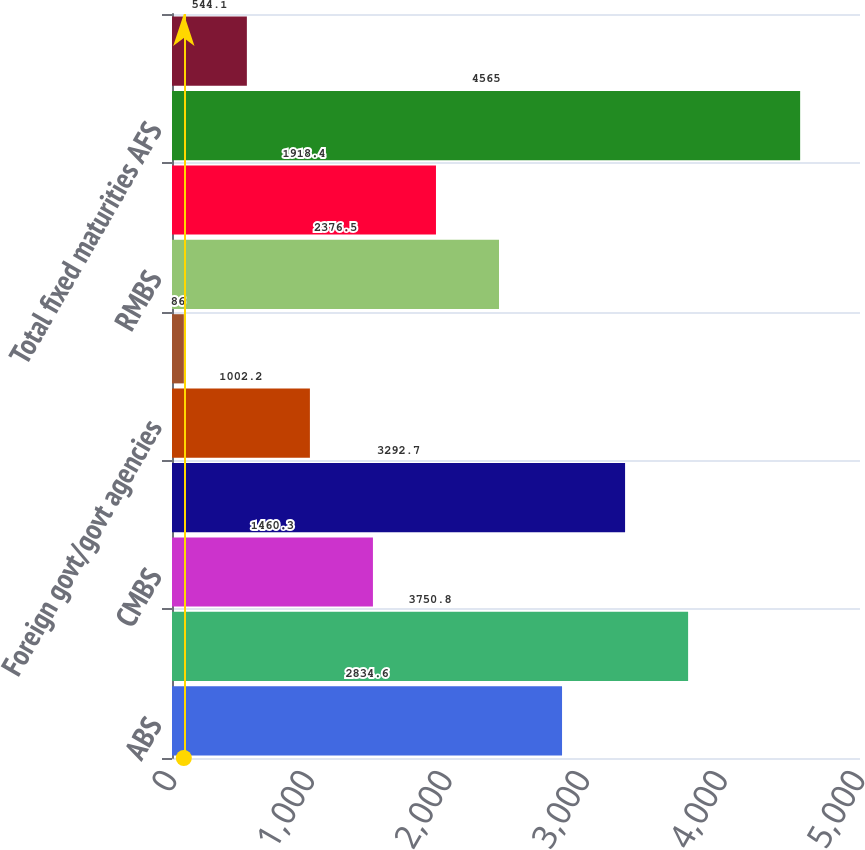Convert chart. <chart><loc_0><loc_0><loc_500><loc_500><bar_chart><fcel>ABS<fcel>CDOs 1<fcel>CMBS<fcel>Corporate<fcel>Foreign govt/govt agencies<fcel>Municipal<fcel>RMBS<fcel>US Treasuries<fcel>Total fixed maturities AFS<fcel>Equity securities AFS 2<nl><fcel>2834.6<fcel>3750.8<fcel>1460.3<fcel>3292.7<fcel>1002.2<fcel>86<fcel>2376.5<fcel>1918.4<fcel>4565<fcel>544.1<nl></chart> 